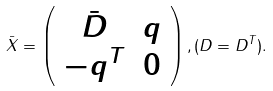Convert formula to latex. <formula><loc_0><loc_0><loc_500><loc_500>\bar { X } = \left ( \begin{array} { c c } \bar { D } & q \\ - q ^ { T } & 0 \end{array} \right ) , ( D = D ^ { T } ) .</formula> 